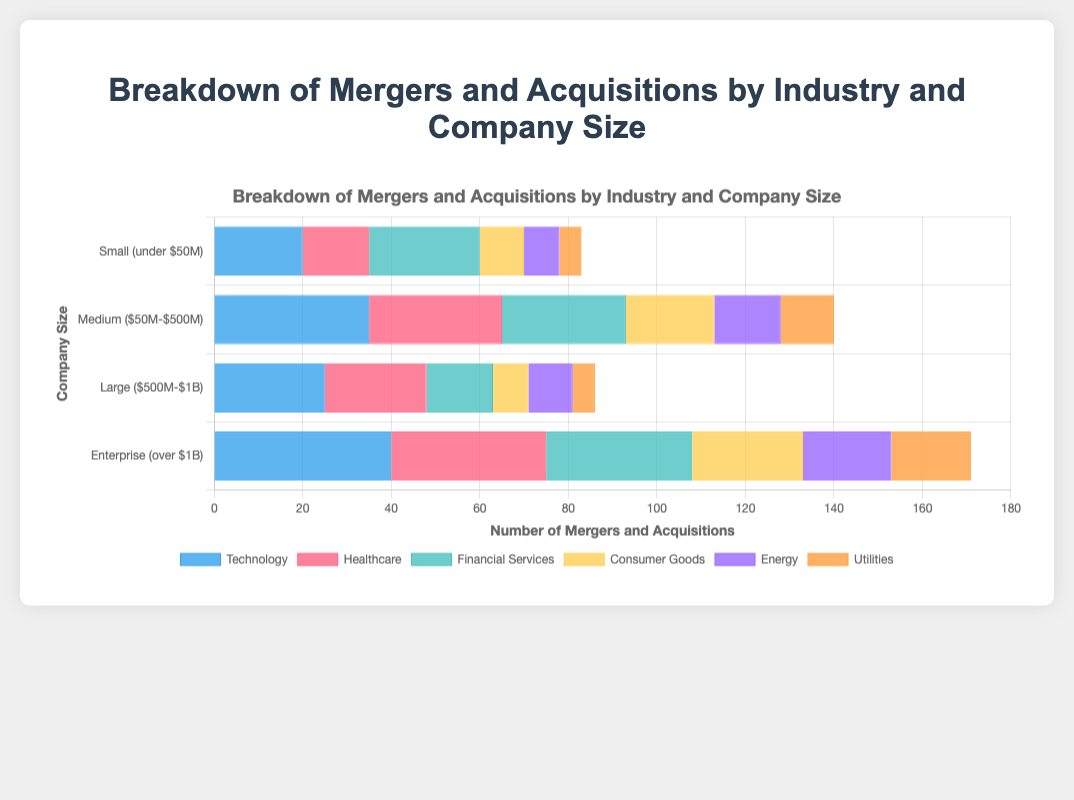What's the total number of mergers and acquisitions in the Technology sector for all company sizes? To find the total, sum up the number of mergers and acquisitions in the Technology sector across all company sizes: 20 (Small) + 35 (Medium) + 25 (Large) + 40 (Enterprise). This equals 120.
Answer: 120 Which industry had the highest number of mergers and acquisitions for Enterprise-sized companies? Look at the bar lengths for Enterprise (over $1B) across all industries. The longest bar is in the Technology sector.
Answer: Technology In the Healthcare sector, how many more Medium-sized companies were involved in mergers and acquisitions compared to Large-sized companies? Subtract the number of Large (23) from Medium (30) in the Healthcare sector: 30 - 23 = 7.
Answer: 7 Which company size had the fewest mergers and acquisitions in the Utilities sector? Compare the bar lengths for Utilities across all company sizes. The shortest bar is for Small companies (5).
Answer: Small (under $50M) By how much does the number of mergers and acquisitions in the Consumer Goods sector for Enterprise-sized companies exceed that for Medium-sized companies? Subtract the Medium (20) from Enterprise (25) in the Consumer Goods sector: 25 - 20 = 5.
Answer: 5 What is the sum of mergers and acquisitions in the Energy sector for Small and Large company sizes? Add the number of mergers and acquisitions in the Energy sector for Small (8) and Large (10) companies: 8 + 10 = 18.
Answer: 18 Which sector had the greatest disparity in the number of mergers and acquisitions between Small and Enterprise company sizes? Calculate the difference between Small and Enterprise company sizes for each sector. The largest difference is in the Technology sector: 40 (Enterprise) - 20 (Small) = 20.
Answer: Technology What is the total number of mergers and acquisitions for Medium-sized companies across all industries? Sum the number of mergers and acquisitions for Medium-sized companies across all industries: 35 (Technology) + 30 (Healthcare) + 28 (Financial Services) + 20 (Consumer Goods) + 15 (Energy) + 12 (Utilities). This equals 140.
Answer: 140 